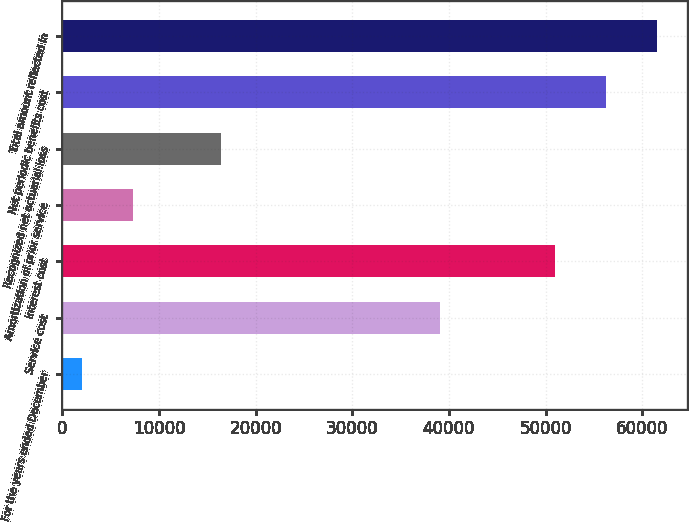Convert chart. <chart><loc_0><loc_0><loc_500><loc_500><bar_chart><fcel>For the years ended December<fcel>Service cost<fcel>Interest cost<fcel>Amortization of prior service<fcel>Recognized net actuarial loss<fcel>Net periodic benefits cost<fcel>Total amount reflected in<nl><fcel>2003<fcel>39096<fcel>50951<fcel>7298.4<fcel>16377<fcel>56246.4<fcel>61541.8<nl></chart> 